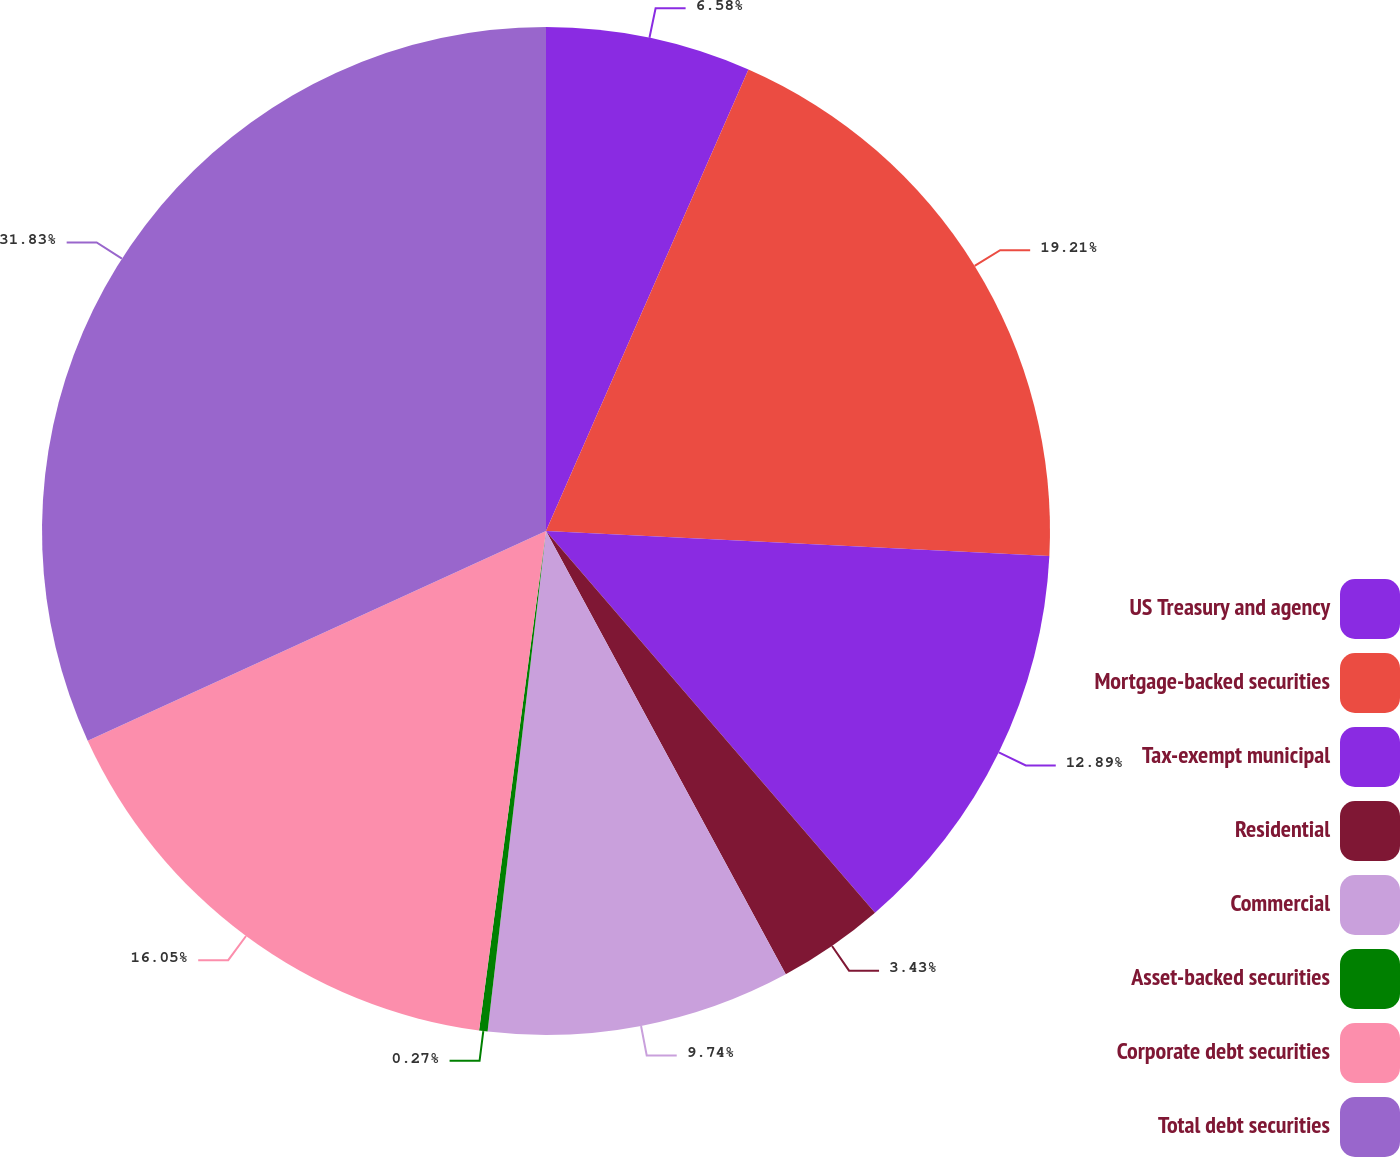Convert chart. <chart><loc_0><loc_0><loc_500><loc_500><pie_chart><fcel>US Treasury and agency<fcel>Mortgage-backed securities<fcel>Tax-exempt municipal<fcel>Residential<fcel>Commercial<fcel>Asset-backed securities<fcel>Corporate debt securities<fcel>Total debt securities<nl><fcel>6.58%<fcel>19.21%<fcel>12.89%<fcel>3.43%<fcel>9.74%<fcel>0.27%<fcel>16.05%<fcel>31.83%<nl></chart> 